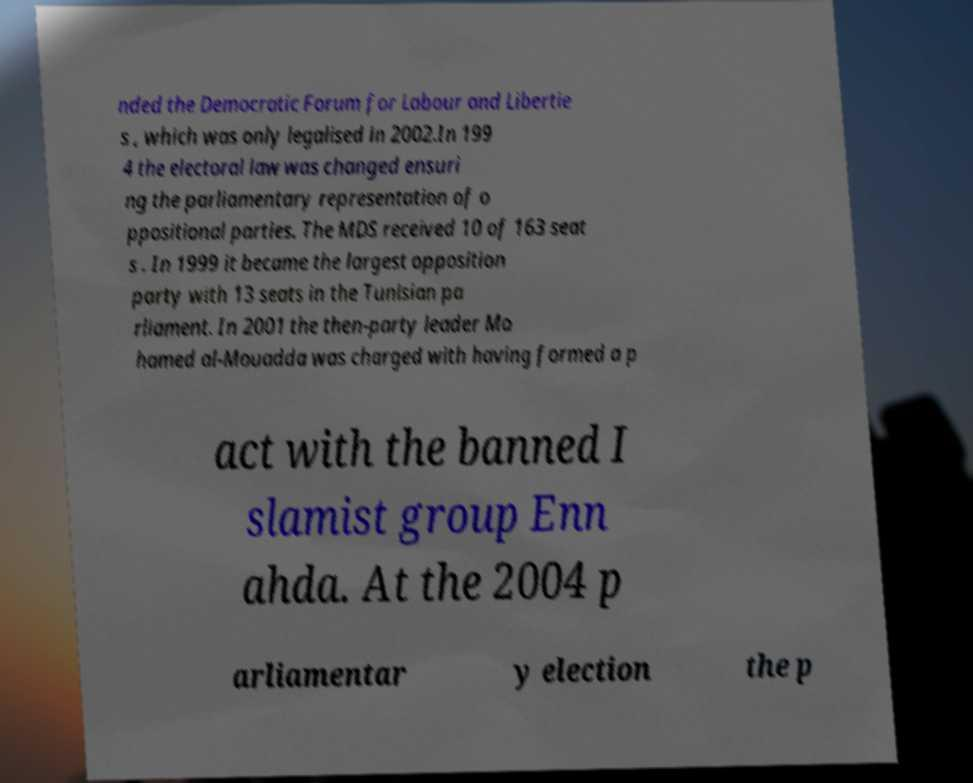Could you extract and type out the text from this image? nded the Democratic Forum for Labour and Libertie s , which was only legalised in 2002.In 199 4 the electoral law was changed ensuri ng the parliamentary representation of o ppositional parties. The MDS received 10 of 163 seat s . In 1999 it became the largest opposition party with 13 seats in the Tunisian pa rliament. In 2001 the then-party leader Mo hamed al-Mouadda was charged with having formed a p act with the banned I slamist group Enn ahda. At the 2004 p arliamentar y election the p 